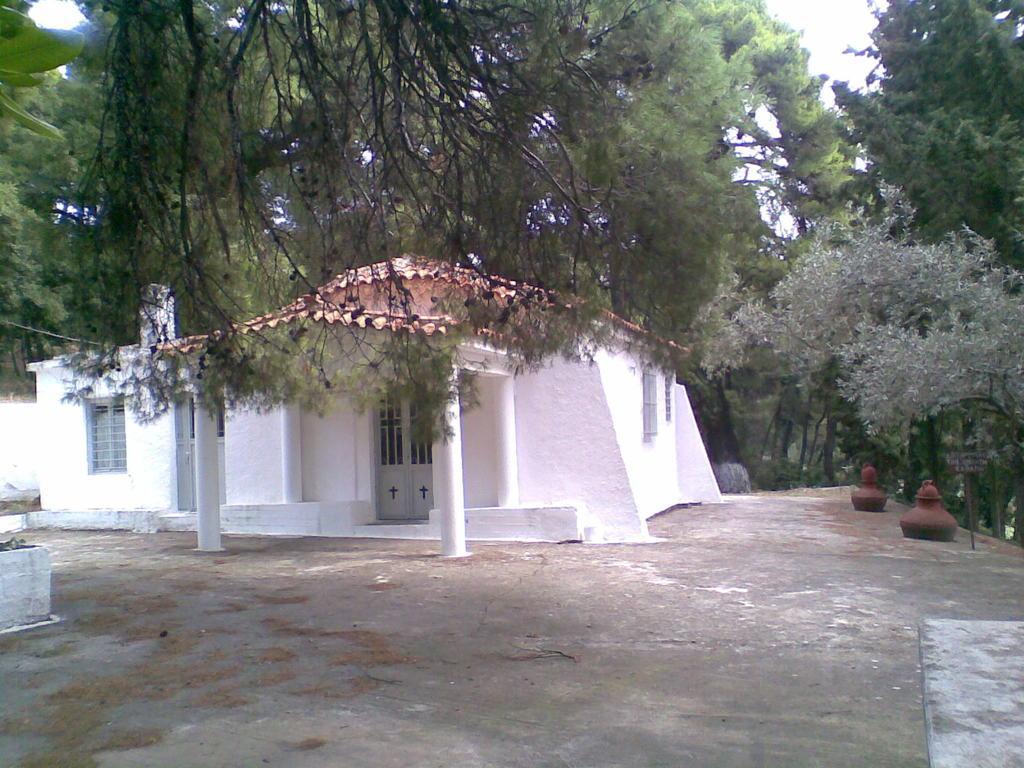Can you describe this image briefly? Here we can see a house, windows and door. Around this house there are trees. 